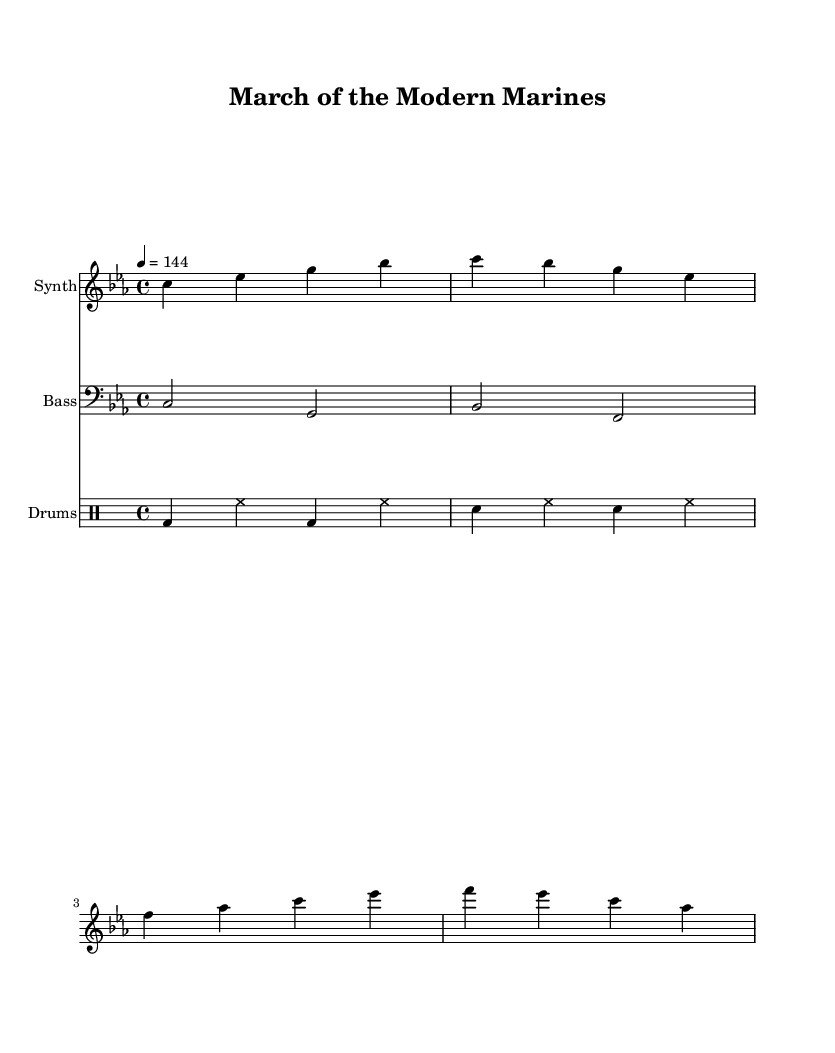What is the key signature of this music? The key signature is C minor, which is indicated by three flats in the key signature. C minor consists of the notes C, D, E-flat, F, G, A-flat, and B-flat.
Answer: C minor What is the time signature of this piece? The time signature is indicated at the beginning of the score and is written as 4/4, which means there are four beats in each measure and a quarter note receives one beat.
Answer: 4/4 What is the tempo marking for this piece? The tempo marking is specified as 144, which indicates that the piece should be played at a speed of 144 beats per minute, specifically in a quarter-note pulse.
Answer: 144 How many measures does the synth part contain? The synth part contains four measures, as indicated by the grouping of bar lines throughout the music. Each measure is separated clearly with vertical lines.
Answer: 4 What type of instrument is playing the bass part? The bass part is indicated with a clef sign that looks like an inverted "F", which represents a bass clef typically used for lower-pitched instruments like the bass guitar or cello.
Answer: Bass Which type of drums are represented in the drum part? The drum part includes bass drum and snare drum as indicated by the specific notation used in the drummode section of the score. The bass drum is denoted by "bd" and snare drum by "sn".
Answer: Bass and snare What is the overall mood suggested by the combination of a military march and EDM elements? The combination of a military march rhythm infused with high-energy EDM elements suggests an upbeat and powerful mood, often characterized by driving beats and a strong sense of rhythm.
Answer: Upbeat and powerful 